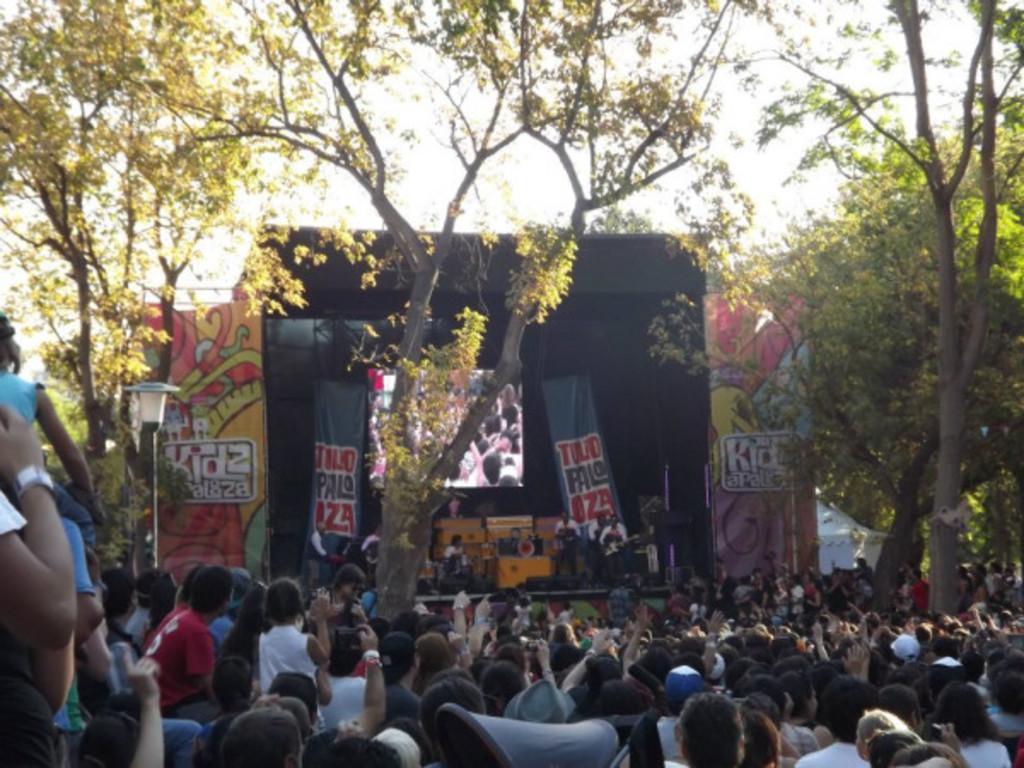Could you give a brief overview of what you see in this image? In the center of the image we can see musical instruments, screen, boards, lights are present. At the bottom of the image a group of people are there. At the top of the image sky is present. In the center of the image trees are there. 